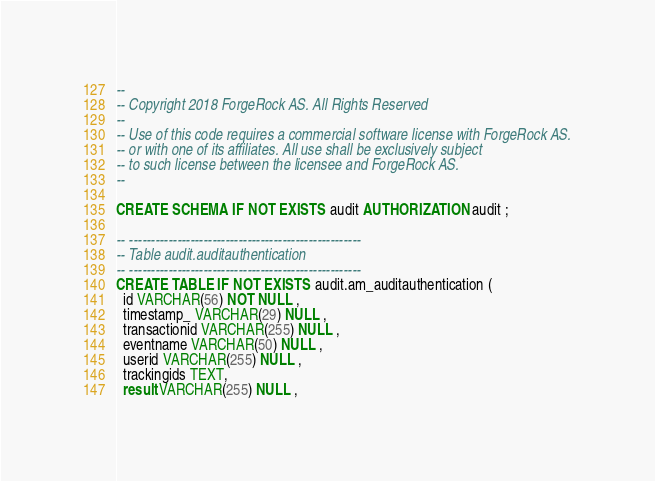<code> <loc_0><loc_0><loc_500><loc_500><_SQL_>--
-- Copyright 2018 ForgeRock AS. All Rights Reserved
--
-- Use of this code requires a commercial software license with ForgeRock AS.
-- or with one of its affiliates. All use shall be exclusively subject
-- to such license between the licensee and ForgeRock AS.
--

CREATE SCHEMA IF NOT EXISTS audit AUTHORIZATION audit ;

-- -----------------------------------------------------
-- Table audit.auditauthentication
-- -----------------------------------------------------
CREATE TABLE IF NOT EXISTS audit.am_auditauthentication (
  id VARCHAR(56) NOT NULL ,
  timestamp_ VARCHAR(29) NULL ,
  transactionid VARCHAR(255) NULL ,
  eventname VARCHAR(50) NULL ,
  userid VARCHAR(255) NULL ,
  trackingids TEXT,
  result VARCHAR(255) NULL ,</code> 